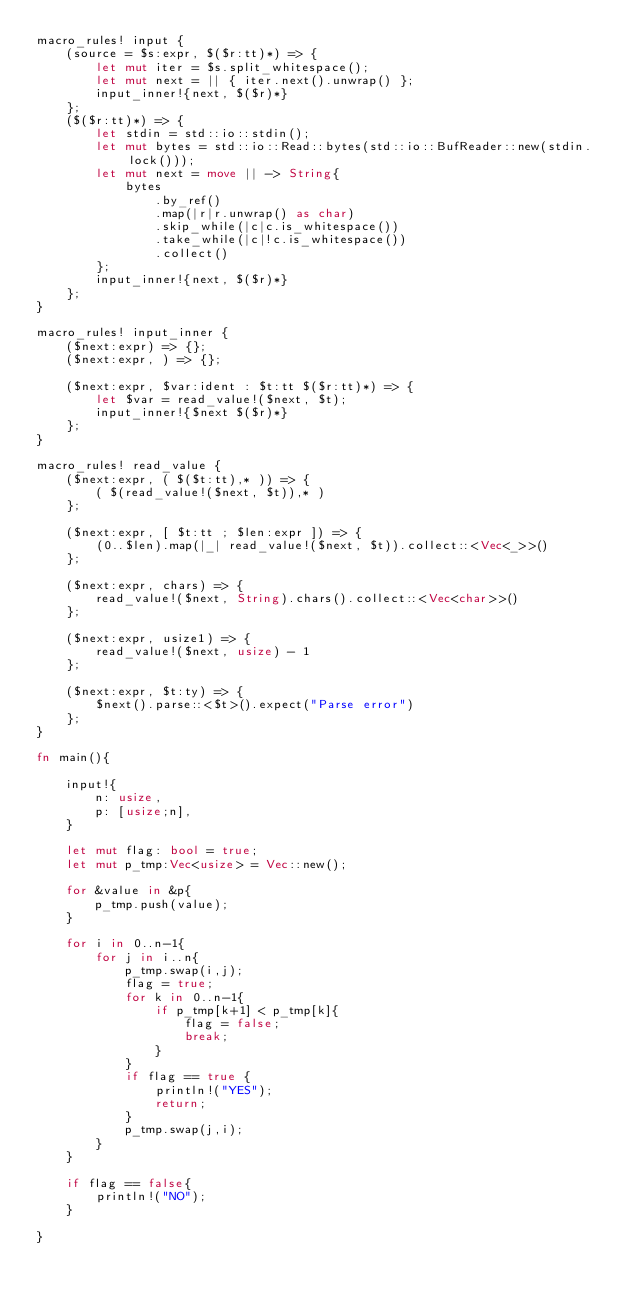Convert code to text. <code><loc_0><loc_0><loc_500><loc_500><_Rust_>macro_rules! input {
    (source = $s:expr, $($r:tt)*) => {
        let mut iter = $s.split_whitespace();
        let mut next = || { iter.next().unwrap() };
        input_inner!{next, $($r)*}
    };
    ($($r:tt)*) => {
        let stdin = std::io::stdin();
        let mut bytes = std::io::Read::bytes(std::io::BufReader::new(stdin.lock()));
        let mut next = move || -> String{
            bytes
                .by_ref()
                .map(|r|r.unwrap() as char)
                .skip_while(|c|c.is_whitespace())
                .take_while(|c|!c.is_whitespace())
                .collect()
        };
        input_inner!{next, $($r)*}
    };
}

macro_rules! input_inner {
    ($next:expr) => {};
    ($next:expr, ) => {};

    ($next:expr, $var:ident : $t:tt $($r:tt)*) => {
        let $var = read_value!($next, $t);
        input_inner!{$next $($r)*}
    };
}

macro_rules! read_value {
    ($next:expr, ( $($t:tt),* )) => {
        ( $(read_value!($next, $t)),* )
    };

    ($next:expr, [ $t:tt ; $len:expr ]) => {
        (0..$len).map(|_| read_value!($next, $t)).collect::<Vec<_>>()
    };

    ($next:expr, chars) => {
        read_value!($next, String).chars().collect::<Vec<char>>()
    };

    ($next:expr, usize1) => {
        read_value!($next, usize) - 1
    };

    ($next:expr, $t:ty) => {
        $next().parse::<$t>().expect("Parse error")
    };
}

fn main(){

    input!{
        n: usize,
        p: [usize;n],
    }

    let mut flag: bool = true;
    let mut p_tmp:Vec<usize> = Vec::new();

    for &value in &p{
        p_tmp.push(value);
    }
    
    for i in 0..n-1{
        for j in i..n{
            p_tmp.swap(i,j);
            flag = true;
            for k in 0..n-1{
                if p_tmp[k+1] < p_tmp[k]{
                    flag = false;  
                    break;
                }
            }   
            if flag == true {
                println!("YES");
                return;
            }
            p_tmp.swap(j,i);
        }
    }

    if flag == false{
        println!("NO");
    }

}</code> 